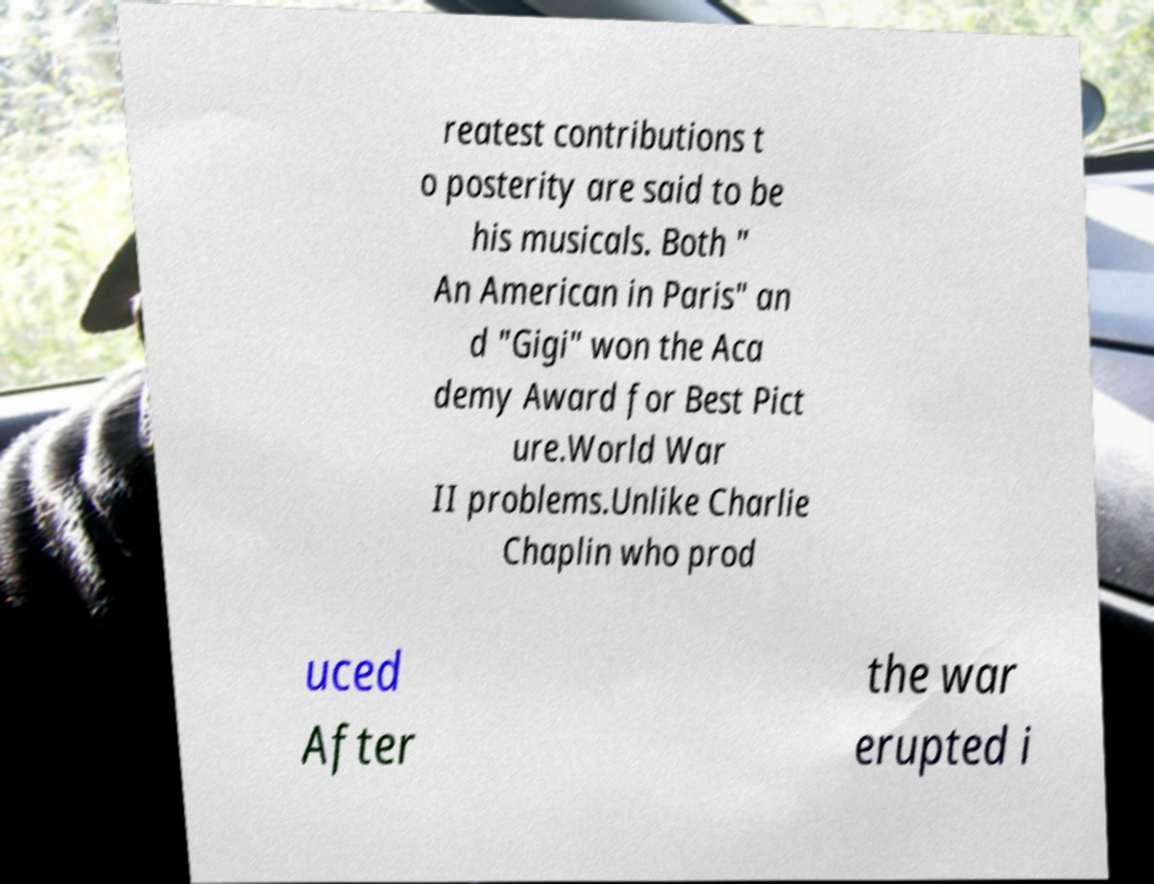Please read and relay the text visible in this image. What does it say? reatest contributions t o posterity are said to be his musicals. Both " An American in Paris" an d "Gigi" won the Aca demy Award for Best Pict ure.World War II problems.Unlike Charlie Chaplin who prod uced After the war erupted i 